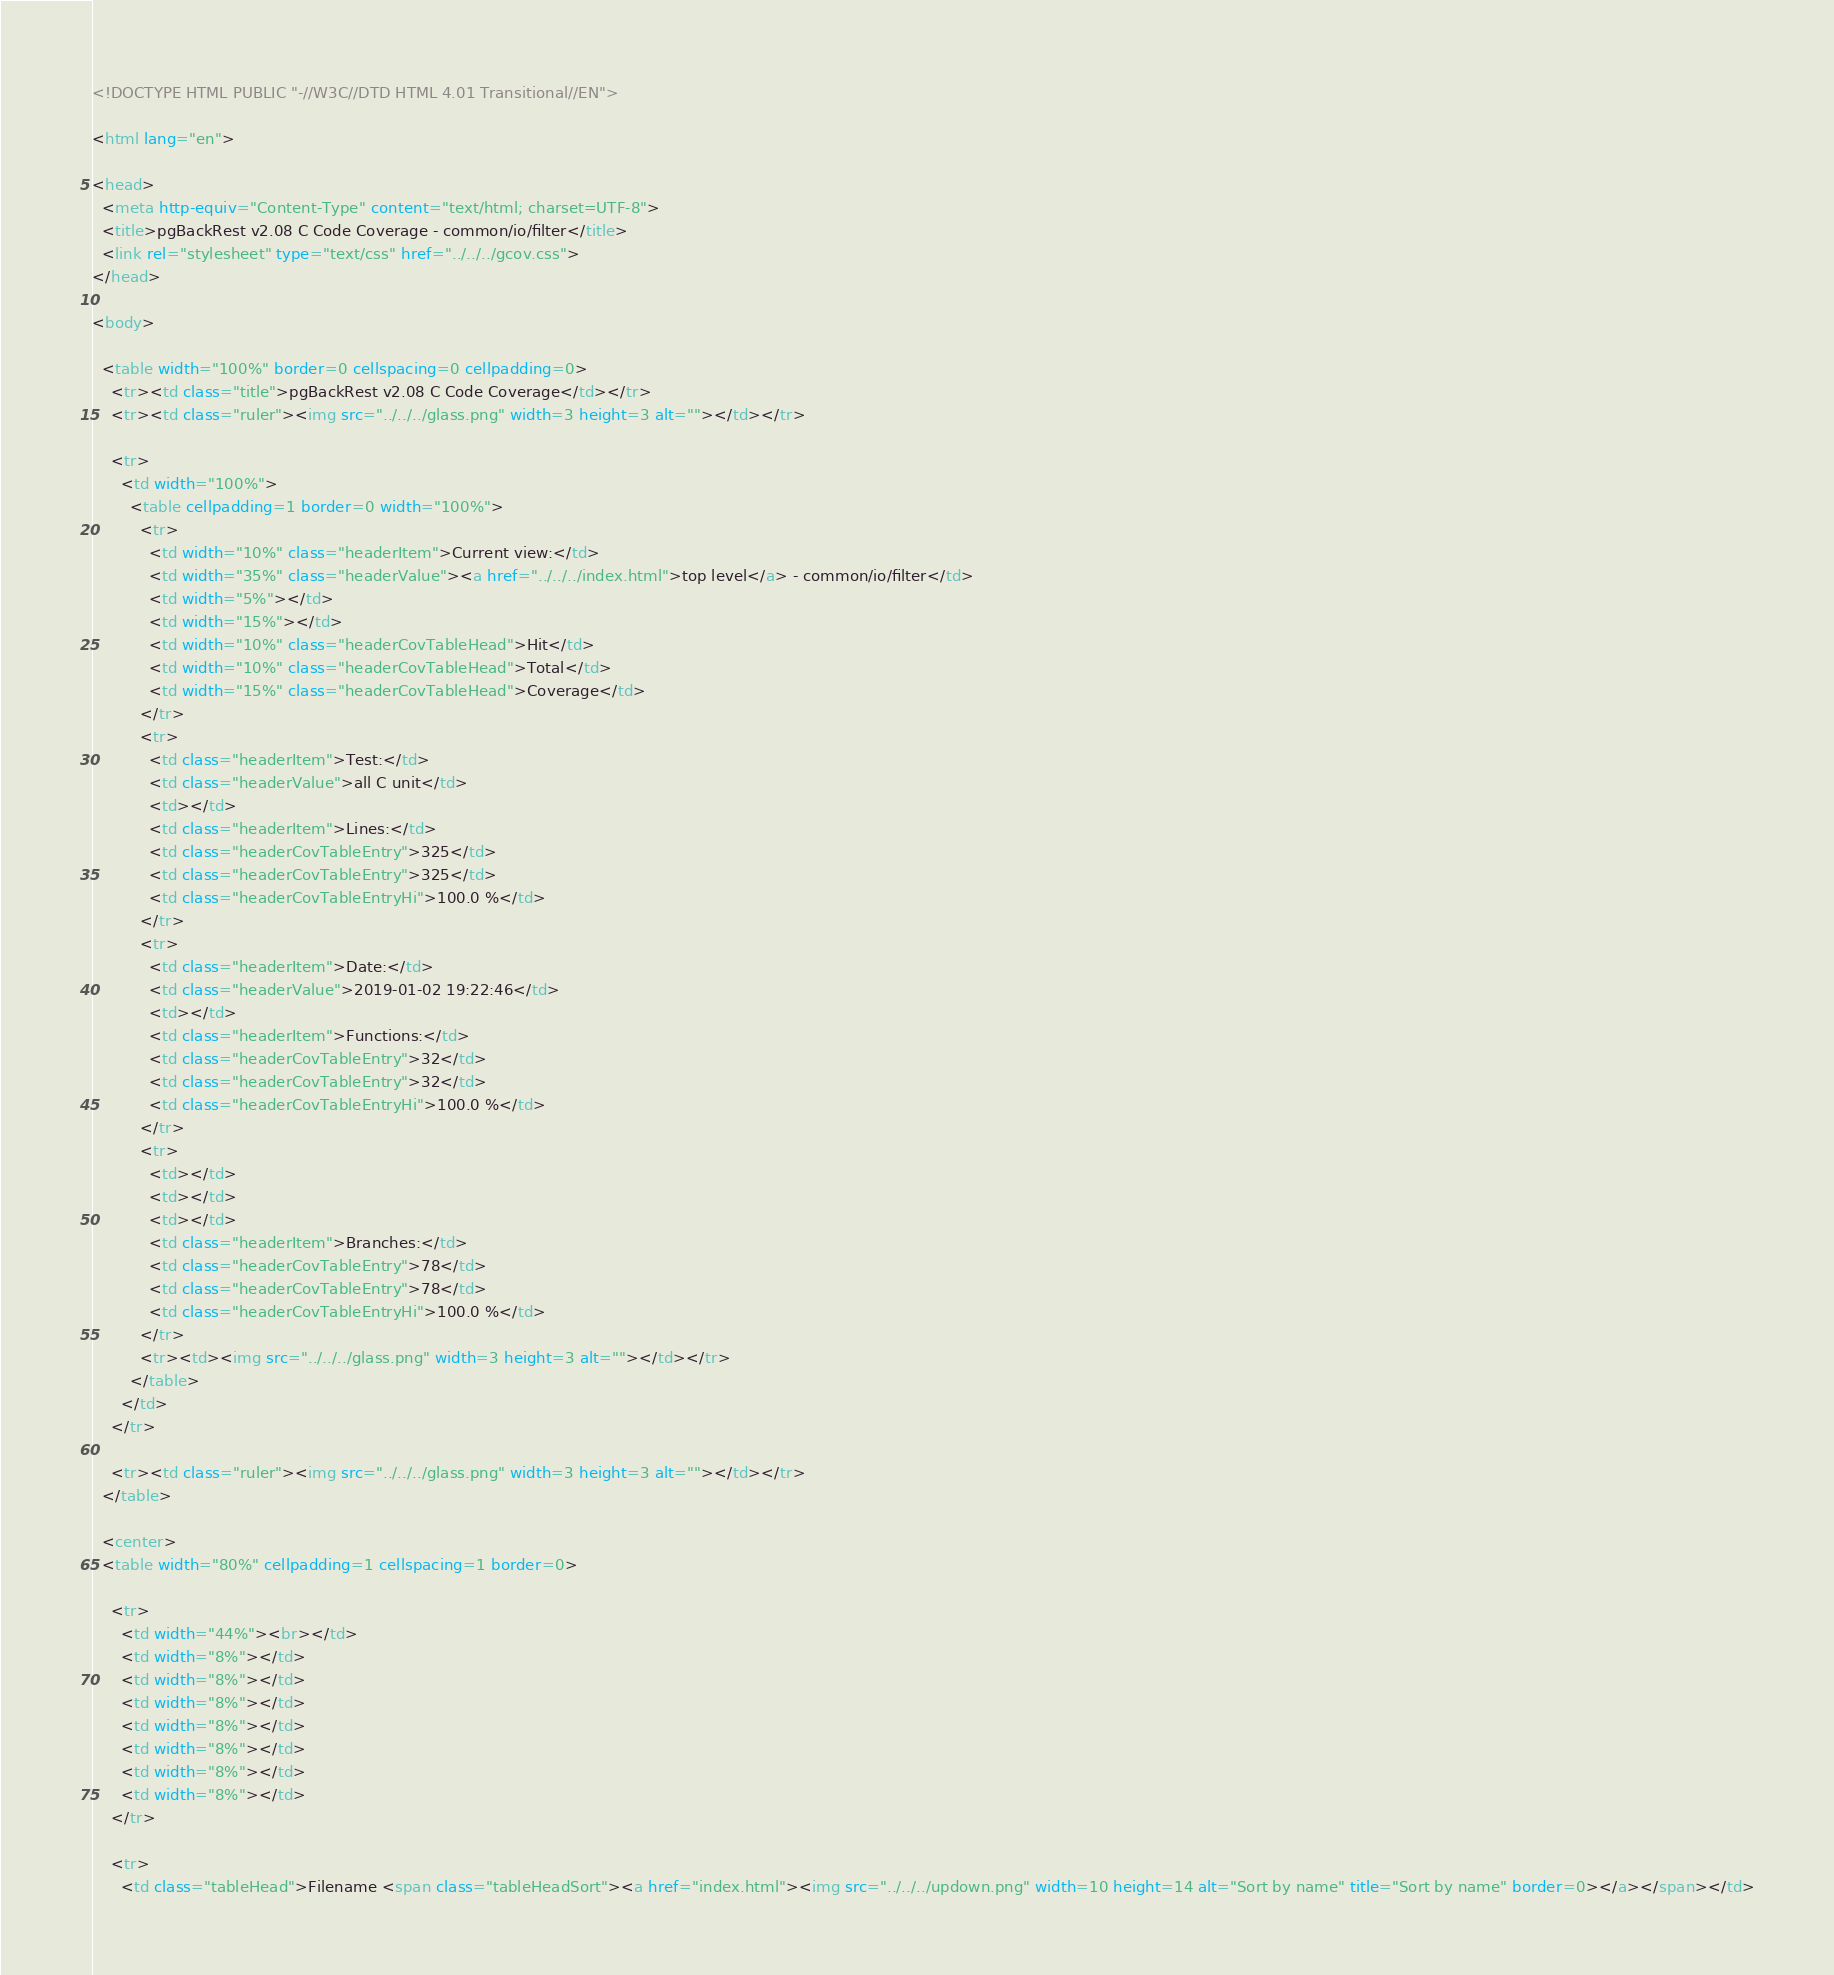<code> <loc_0><loc_0><loc_500><loc_500><_HTML_><!DOCTYPE HTML PUBLIC "-//W3C//DTD HTML 4.01 Transitional//EN">

<html lang="en">

<head>
  <meta http-equiv="Content-Type" content="text/html; charset=UTF-8">
  <title>pgBackRest v2.08 C Code Coverage - common/io/filter</title>
  <link rel="stylesheet" type="text/css" href="../../../gcov.css">
</head>

<body>

  <table width="100%" border=0 cellspacing=0 cellpadding=0>
    <tr><td class="title">pgBackRest v2.08 C Code Coverage</td></tr>
    <tr><td class="ruler"><img src="../../../glass.png" width=3 height=3 alt=""></td></tr>

    <tr>
      <td width="100%">
        <table cellpadding=1 border=0 width="100%">
          <tr>
            <td width="10%" class="headerItem">Current view:</td>
            <td width="35%" class="headerValue"><a href="../../../index.html">top level</a> - common/io/filter</td>
            <td width="5%"></td>
            <td width="15%"></td>
            <td width="10%" class="headerCovTableHead">Hit</td>
            <td width="10%" class="headerCovTableHead">Total</td>
            <td width="15%" class="headerCovTableHead">Coverage</td>
          </tr>
          <tr>
            <td class="headerItem">Test:</td>
            <td class="headerValue">all C unit</td>
            <td></td>
            <td class="headerItem">Lines:</td>
            <td class="headerCovTableEntry">325</td>
            <td class="headerCovTableEntry">325</td>
            <td class="headerCovTableEntryHi">100.0 %</td>
          </tr>
          <tr>
            <td class="headerItem">Date:</td>
            <td class="headerValue">2019-01-02 19:22:46</td>
            <td></td>
            <td class="headerItem">Functions:</td>
            <td class="headerCovTableEntry">32</td>
            <td class="headerCovTableEntry">32</td>
            <td class="headerCovTableEntryHi">100.0 %</td>
          </tr>
          <tr>
            <td></td>
            <td></td>
            <td></td>
            <td class="headerItem">Branches:</td>
            <td class="headerCovTableEntry">78</td>
            <td class="headerCovTableEntry">78</td>
            <td class="headerCovTableEntryHi">100.0 %</td>
          </tr>
          <tr><td><img src="../../../glass.png" width=3 height=3 alt=""></td></tr>
        </table>
      </td>
    </tr>

    <tr><td class="ruler"><img src="../../../glass.png" width=3 height=3 alt=""></td></tr>
  </table>

  <center>
  <table width="80%" cellpadding=1 cellspacing=1 border=0>

    <tr>
      <td width="44%"><br></td>
      <td width="8%"></td>
      <td width="8%"></td>
      <td width="8%"></td>
      <td width="8%"></td>
      <td width="8%"></td>
      <td width="8%"></td>
      <td width="8%"></td>
    </tr>

    <tr>
      <td class="tableHead">Filename <span class="tableHeadSort"><a href="index.html"><img src="../../../updown.png" width=10 height=14 alt="Sort by name" title="Sort by name" border=0></a></span></td></code> 